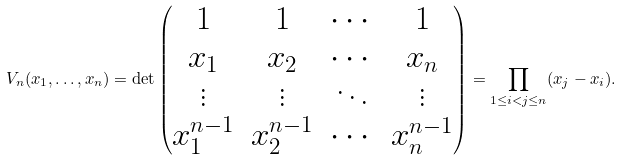Convert formula to latex. <formula><loc_0><loc_0><loc_500><loc_500>V _ { n } ( x _ { 1 } , \dots , x _ { n } ) = \det \begin{pmatrix} 1 & 1 & \cdots & 1 \\ x _ { 1 } & x _ { 2 } & \cdots & x _ { n } \\ \vdots & \vdots & \ddots & \vdots \\ x _ { 1 } ^ { n - 1 } & x _ { 2 } ^ { n - 1 } & \cdots & x _ { n } ^ { n - 1 } \end{pmatrix} = \prod _ { 1 \leq i < j \leq n } ( x _ { j } - x _ { i } ) .</formula> 